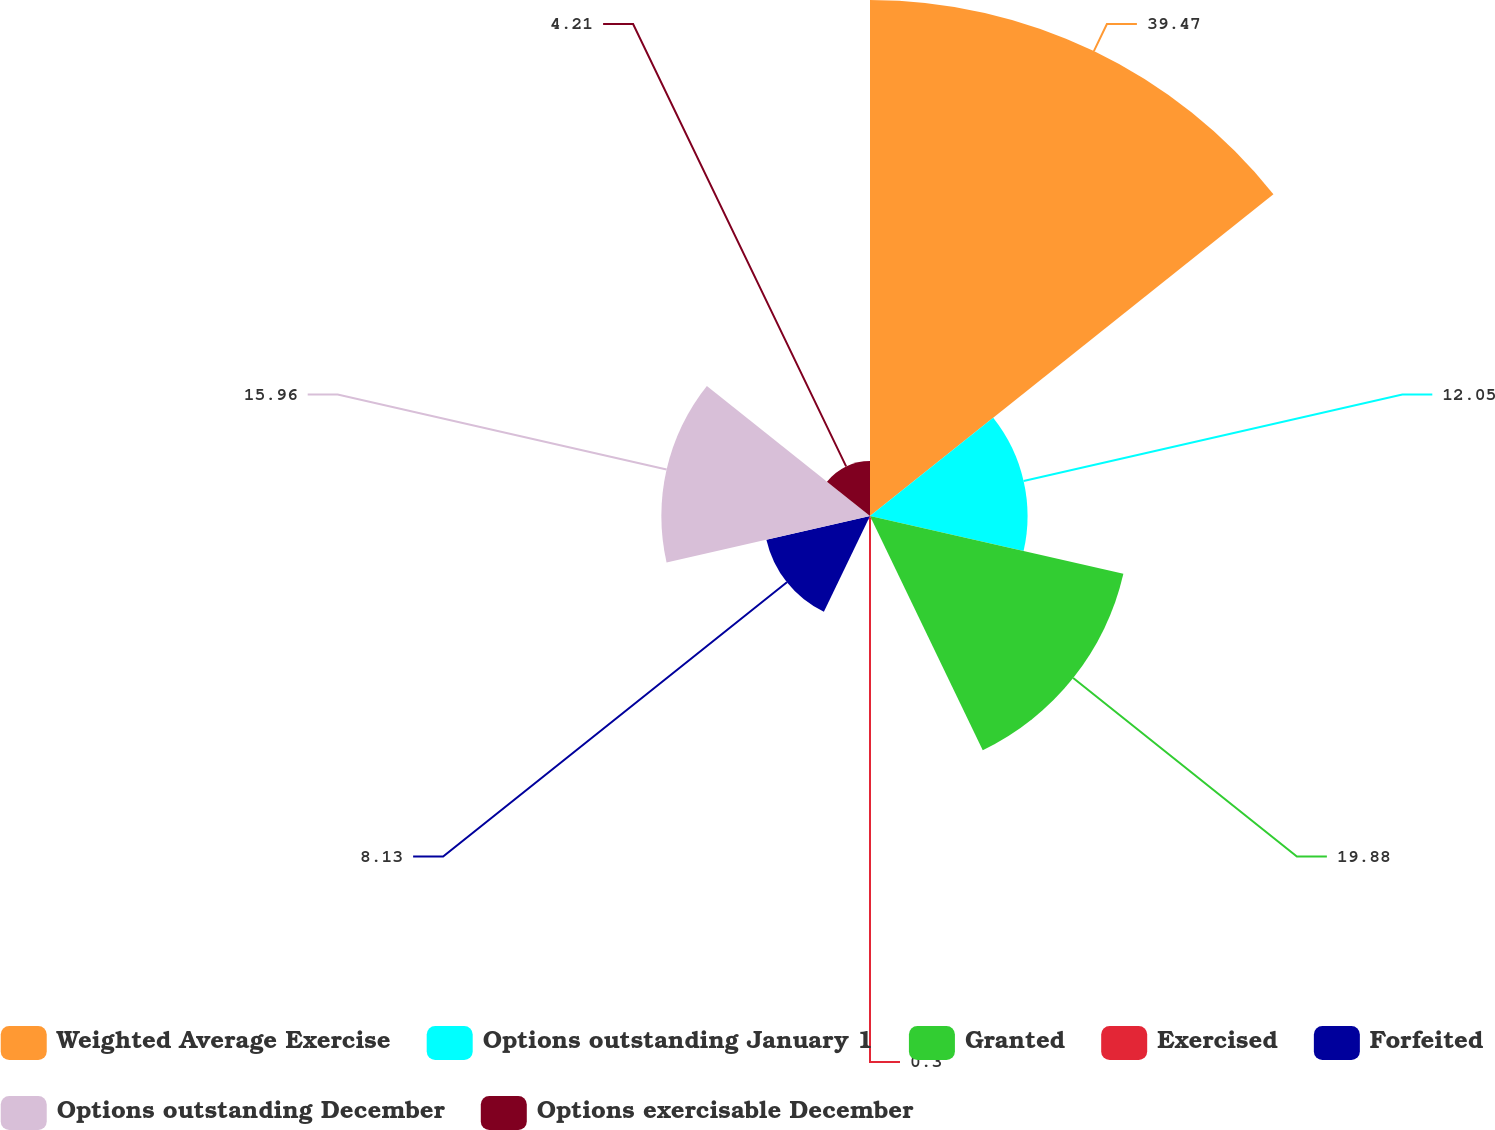<chart> <loc_0><loc_0><loc_500><loc_500><pie_chart><fcel>Weighted Average Exercise<fcel>Options outstanding January 1<fcel>Granted<fcel>Exercised<fcel>Forfeited<fcel>Options outstanding December<fcel>Options exercisable December<nl><fcel>39.47%<fcel>12.05%<fcel>19.88%<fcel>0.3%<fcel>8.13%<fcel>15.96%<fcel>4.21%<nl></chart> 